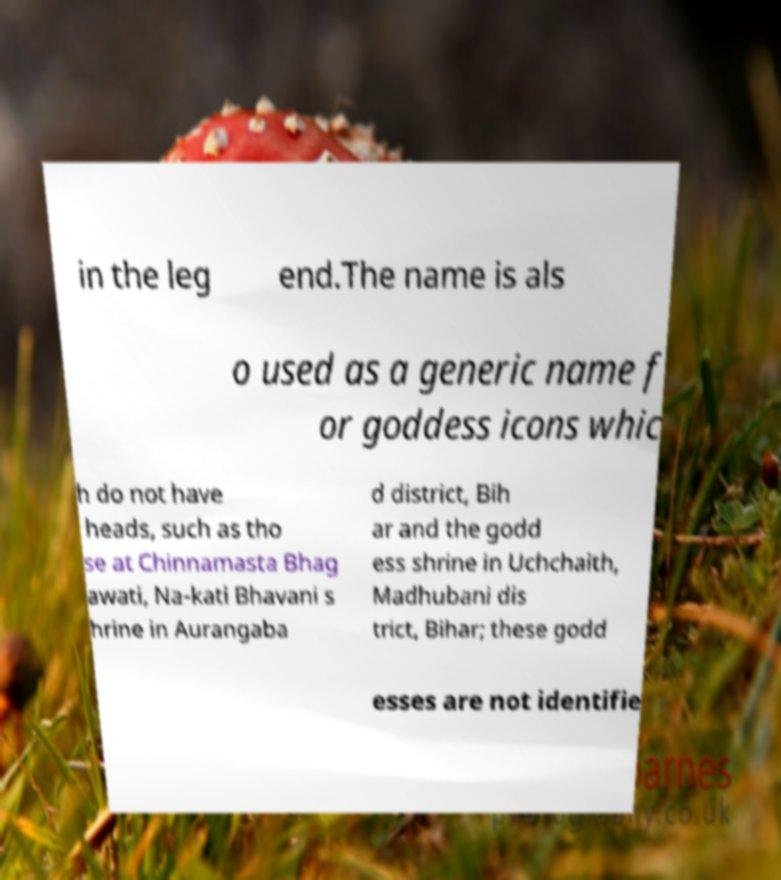Please read and relay the text visible in this image. What does it say? in the leg end.The name is als o used as a generic name f or goddess icons whic h do not have heads, such as tho se at Chinnamasta Bhag awati, Na-kati Bhavani s hrine in Aurangaba d district, Bih ar and the godd ess shrine in Uchchaith, Madhubani dis trict, Bihar; these godd esses are not identifie 